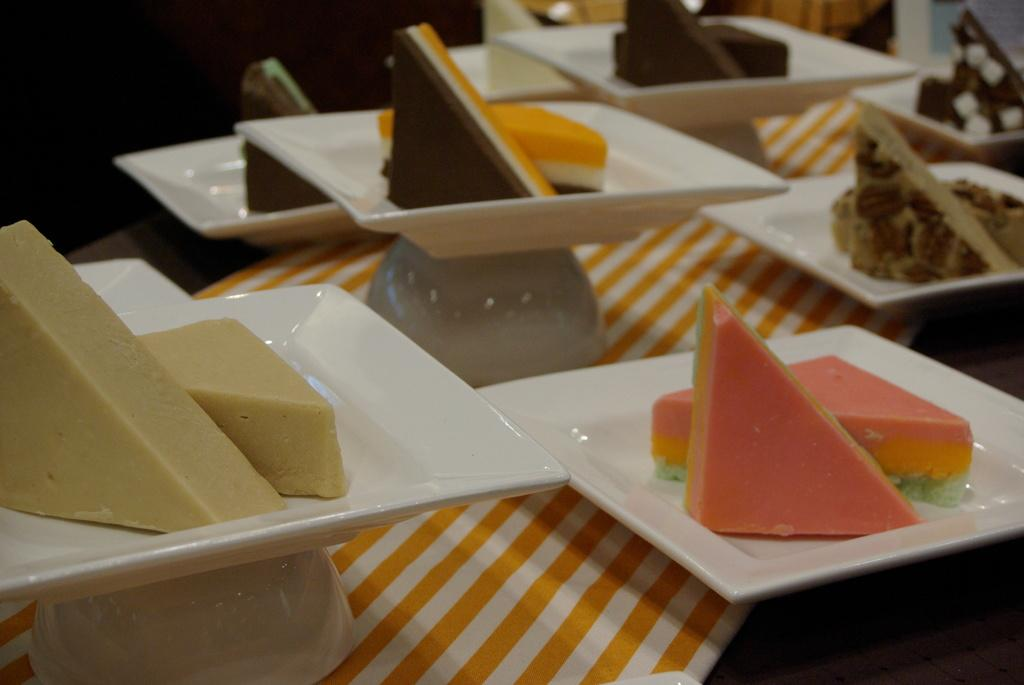What type of food is featured in the image? The image contains cakes and desserts. How are the cakes and desserts presented in the image? The cakes and desserts are placed on plates. What is the surface on which the plates are placed? There is a table in the image. What is covering the table in the image? The table is covered with a cloth. What type of whip is used to create the designs on the cakes in the image? There is no whip or specific design mentioned in the image; it only shows cakes and desserts on plates. 